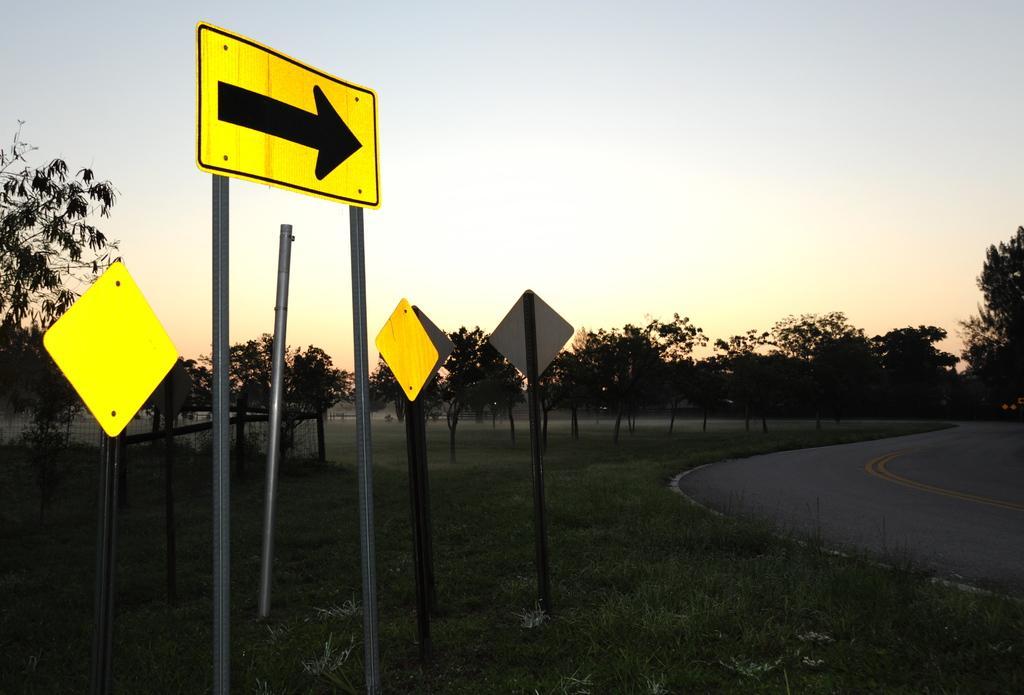Describe this image in one or two sentences. In this image there are few sign boards on the surface of the grass, there is a road, trees and the sky. 